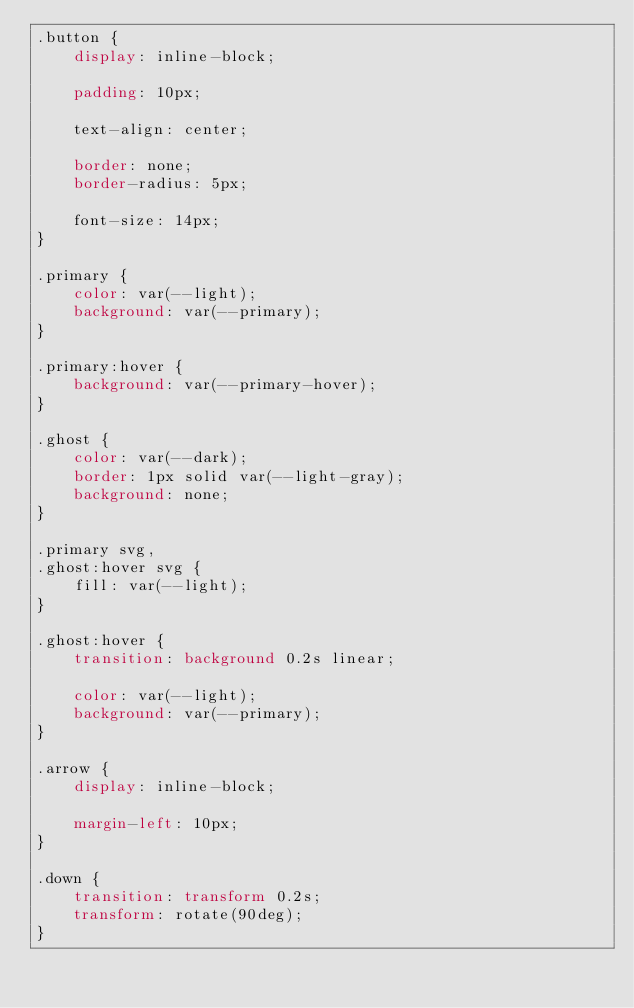<code> <loc_0><loc_0><loc_500><loc_500><_CSS_>.button {
	display: inline-block;

	padding: 10px;

	text-align: center;

	border: none;
	border-radius: 5px;

	font-size: 14px;
}

.primary {
	color: var(--light);
	background: var(--primary);
}

.primary:hover {
	background: var(--primary-hover);
}

.ghost {
	color: var(--dark);
	border: 1px solid var(--light-gray);
	background: none;
}

.primary svg,
.ghost:hover svg {
	fill: var(--light);
}

.ghost:hover {
	transition: background 0.2s linear;

	color: var(--light);
	background: var(--primary);
}

.arrow {
	display: inline-block;

	margin-left: 10px;
}

.down {
	transition: transform 0.2s;
	transform: rotate(90deg);
}
</code> 